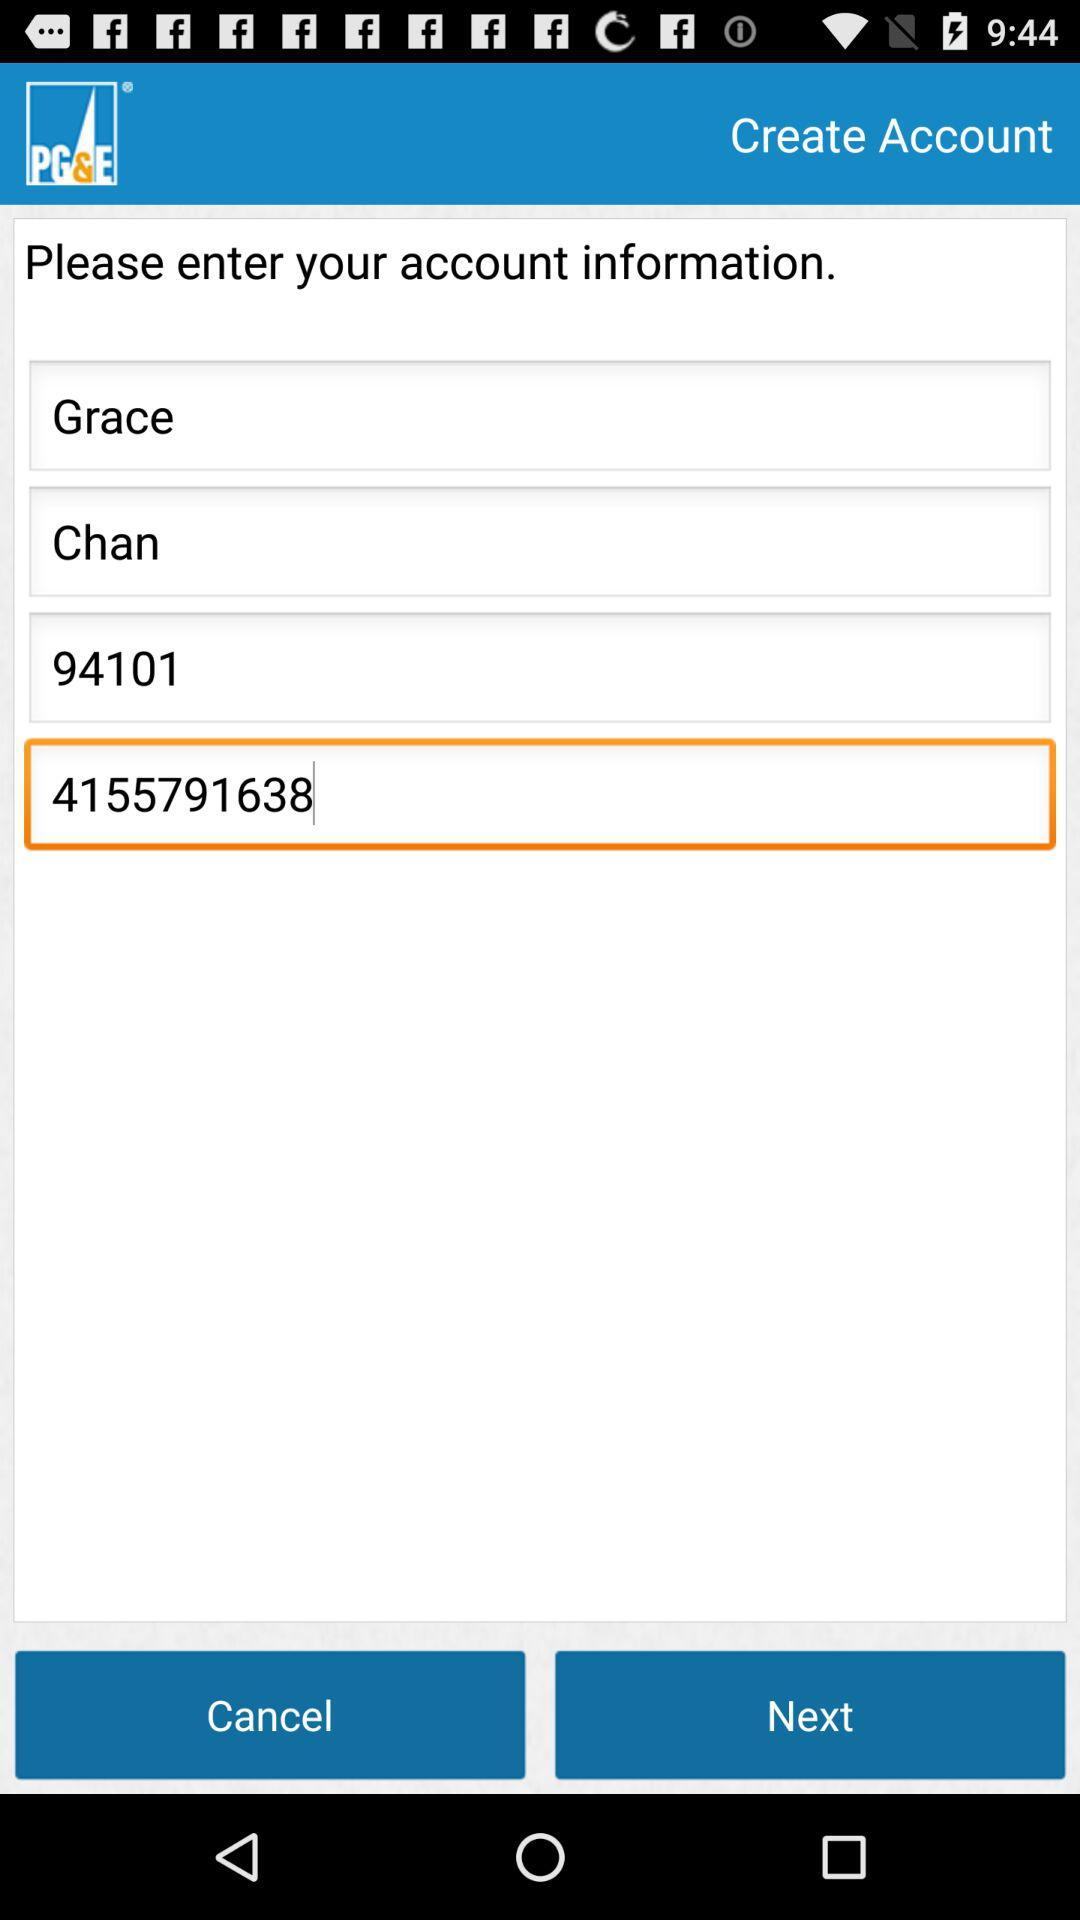What is the application name? The application name is "PG&E". 